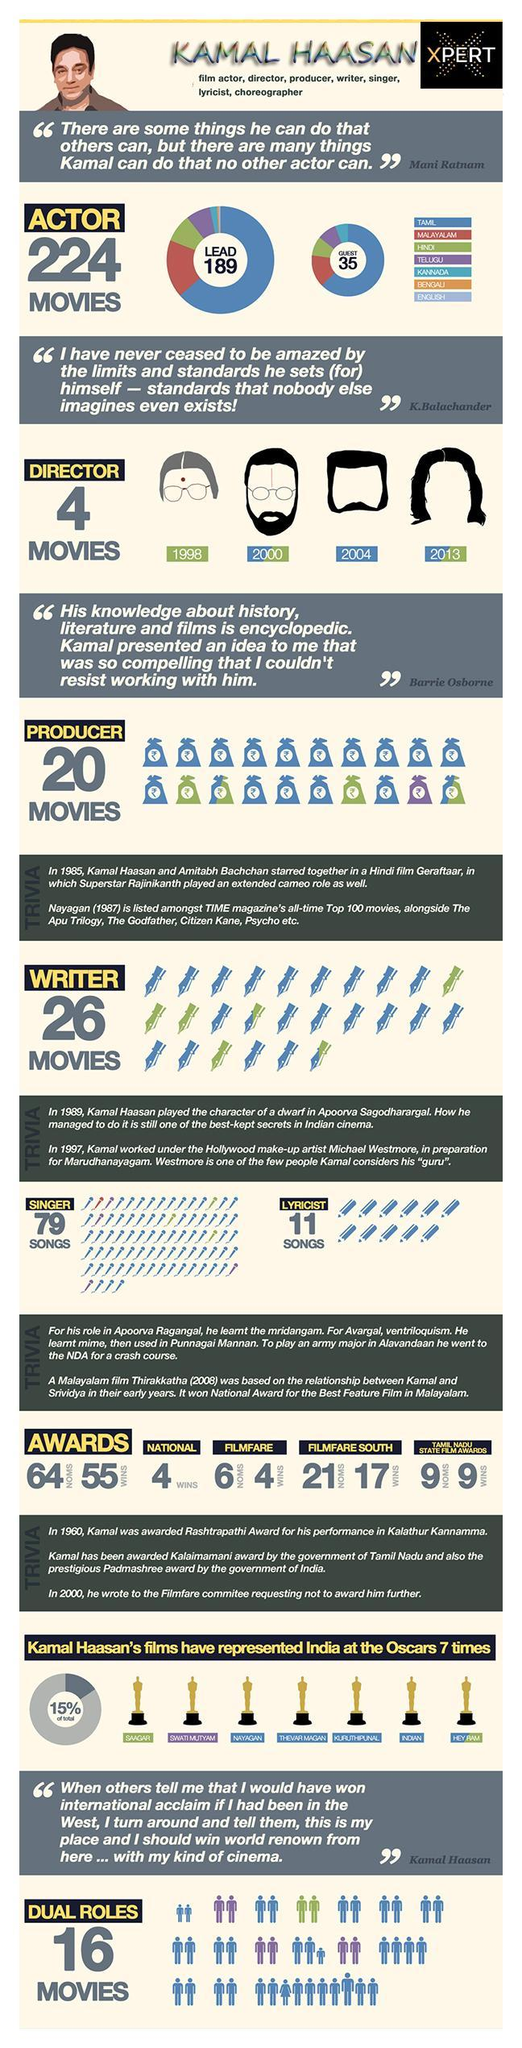The movie directed by Kamal Haasan in 1998 was in which language?
Answer the question with a short phrase. Hindi How many times did he win Tamil Nadu State Film Award? 9 How many Telugu movies did he produce? 1 In how many Telugu movies has he played dual roles? 3 In which language did he write lyrics for songs? Tamil In which language has he played the most number of lead roles? Tamil How many National Awards were won by Kamal Haasan? 4 How many languages have been listed? 7 How many Filmfare awards did he win? 4 The second highest number of lead roles were in which language? Malayalam 